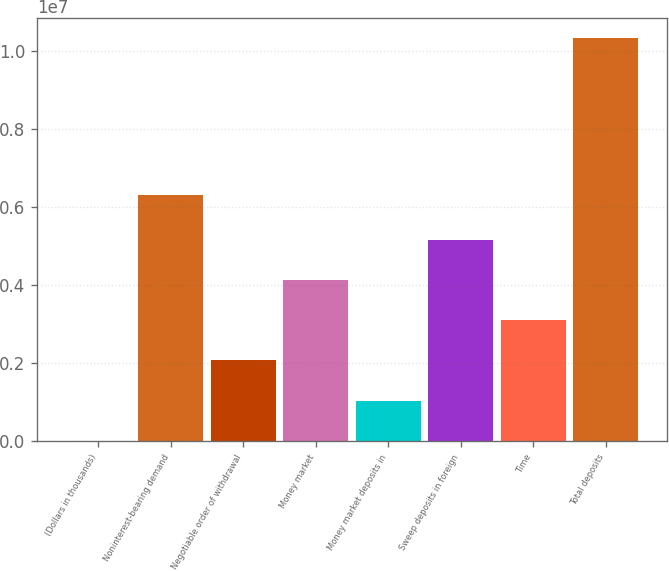Convert chart to OTSL. <chart><loc_0><loc_0><loc_500><loc_500><bar_chart><fcel>(Dollars in thousands)<fcel>Noninterest-bearing demand<fcel>Negotiable order of withdrawal<fcel>Money market<fcel>Money market deposits in<fcel>Sweep deposits in foreign<fcel>Time<fcel>Total deposits<nl><fcel>2009<fcel>6.29899e+06<fcel>2.06799e+06<fcel>4.13398e+06<fcel>1.035e+06<fcel>5.16697e+06<fcel>3.10099e+06<fcel>1.03319e+07<nl></chart> 